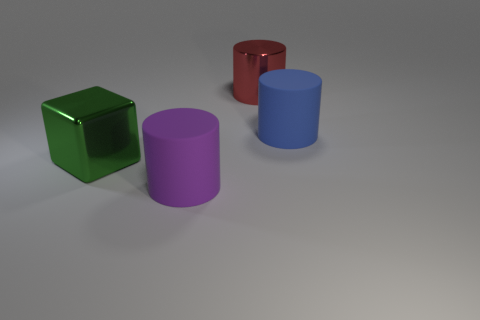Is there any other thing that is the same shape as the green metallic object?
Ensure brevity in your answer.  No. Is the number of large green blocks that are on the right side of the blue cylinder less than the number of rubber cylinders that are on the right side of the large red thing?
Provide a short and direct response. Yes. What number of other cubes are the same material as the big green block?
Offer a terse response. 0. There is a thing that is on the right side of the large metal object behind the big matte cylinder that is behind the large purple matte cylinder; how big is it?
Provide a succinct answer. Large. Are there more green objects to the left of the red object than large green shiny cubes that are on the left side of the big green metal thing?
Provide a short and direct response. Yes. What number of large objects are in front of the metal thing that is on the left side of the purple matte cylinder?
Offer a very short reply. 1. Is there a big metal block of the same color as the large metal cylinder?
Make the answer very short. No. Is the blue rubber object the same size as the green metallic thing?
Ensure brevity in your answer.  Yes. There is a big cylinder that is in front of the large rubber cylinder behind the big purple matte object; what is it made of?
Offer a terse response. Rubber. There is a big purple thing that is the same shape as the red thing; what material is it?
Keep it short and to the point. Rubber. 